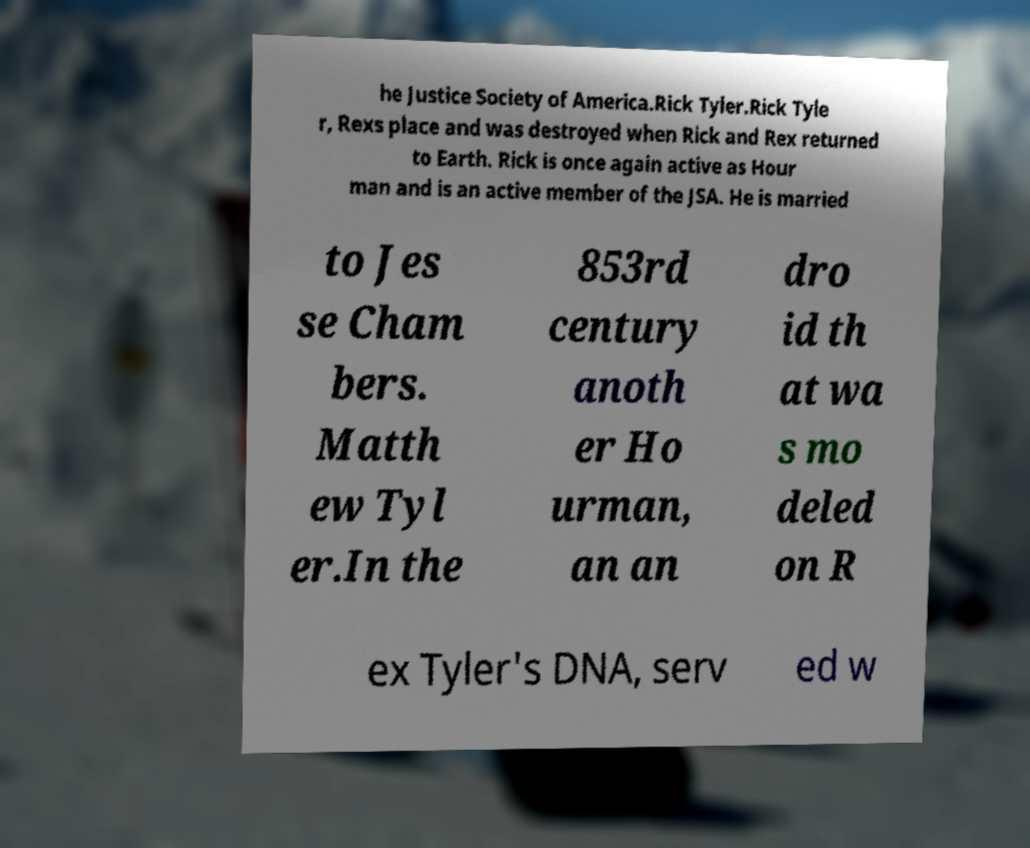Please identify and transcribe the text found in this image. he Justice Society of America.Rick Tyler.Rick Tyle r, Rexs place and was destroyed when Rick and Rex returned to Earth. Rick is once again active as Hour man and is an active member of the JSA. He is married to Jes se Cham bers. Matth ew Tyl er.In the 853rd century anoth er Ho urman, an an dro id th at wa s mo deled on R ex Tyler's DNA, serv ed w 